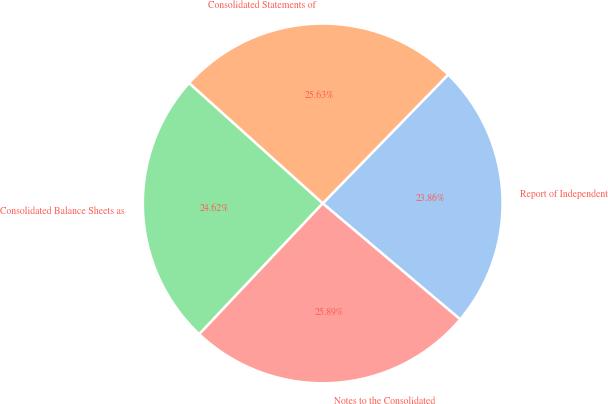Convert chart. <chart><loc_0><loc_0><loc_500><loc_500><pie_chart><fcel>Report of Independent<fcel>Consolidated Statements of<fcel>Consolidated Balance Sheets as<fcel>Notes to the Consolidated<nl><fcel>23.86%<fcel>25.63%<fcel>24.62%<fcel>25.89%<nl></chart> 